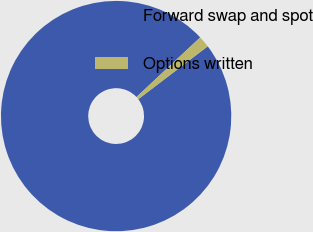Convert chart. <chart><loc_0><loc_0><loc_500><loc_500><pie_chart><fcel>Forward swap and spot<fcel>Options written<nl><fcel>98.39%<fcel>1.61%<nl></chart> 